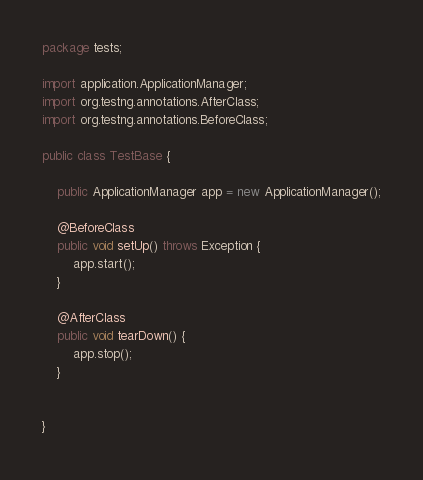<code> <loc_0><loc_0><loc_500><loc_500><_Java_>package tests;

import application.ApplicationManager;
import org.testng.annotations.AfterClass;
import org.testng.annotations.BeforeClass;

public class TestBase {

    public ApplicationManager app = new ApplicationManager();

    @BeforeClass
    public void setUp() throws Exception {
        app.start();
    }

    @AfterClass
    public void tearDown() {
        app.stop();
    }


}
</code> 